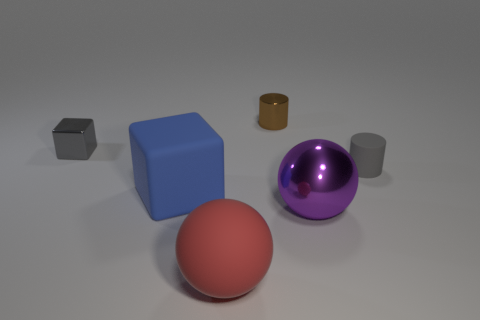There is a large rubber object that is behind the red rubber ball; is there a shiny object that is behind it?
Provide a short and direct response. Yes. What number of cylinders are tiny brown metal things or cyan things?
Offer a terse response. 1. Is there a gray rubber thing that has the same shape as the small brown shiny object?
Offer a very short reply. Yes. The small brown object has what shape?
Provide a succinct answer. Cylinder. How many objects are big purple balls or large red things?
Your answer should be compact. 2. Does the gray thing behind the small matte thing have the same size as the object that is right of the large purple ball?
Your response must be concise. Yes. Are there more tiny gray rubber cylinders on the right side of the large purple object than large blue rubber cubes in front of the blue matte cube?
Provide a short and direct response. Yes. What material is the tiny thing that is behind the gray metallic cube?
Your answer should be very brief. Metal. Is the big purple metallic object the same shape as the small brown shiny object?
Offer a terse response. No. Is there any other thing that has the same color as the small matte cylinder?
Your response must be concise. Yes. 